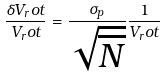Convert formula to latex. <formula><loc_0><loc_0><loc_500><loc_500>\frac { \delta V _ { r } o t } { V _ { r } o t } = \frac { \sigma _ { p } } { \sqrt { \overline { N } } } \frac { 1 } { V _ { r } o t }</formula> 